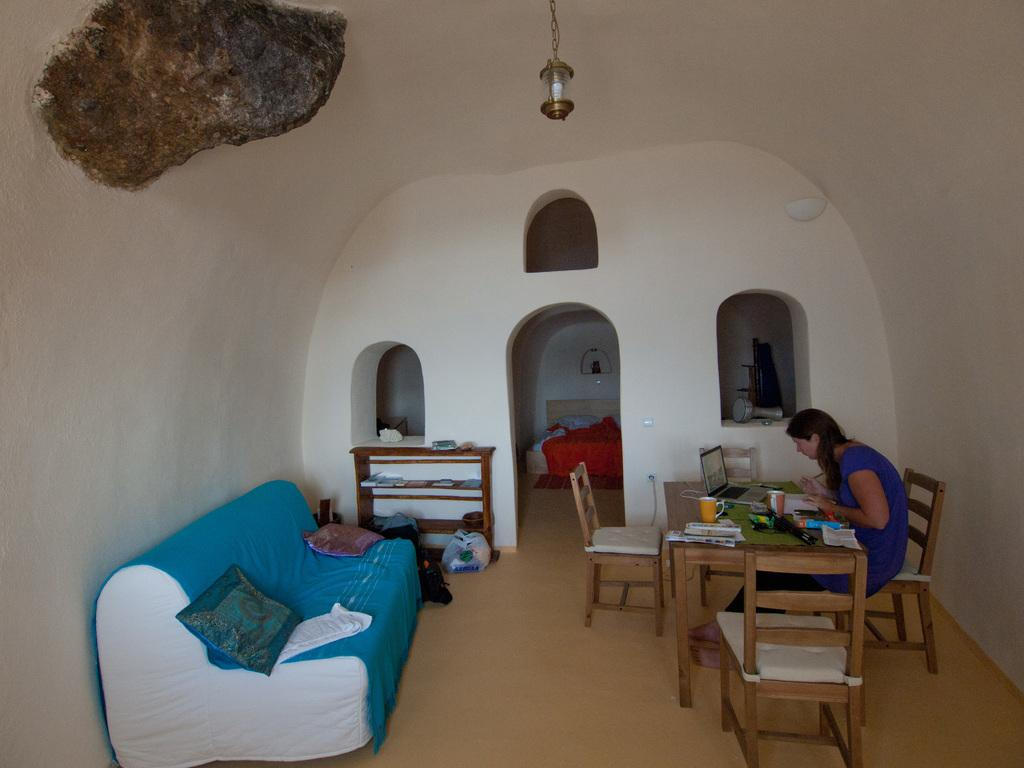What is the woman in the image doing? The woman is sitting on a chair in the image. How many chairs are visible in the image? There are additional chairs in the image. What other furniture is present in the image? There is a table and a sofa with cushions in the image. What color is the crayon on the sofa in the image? There is no crayon present on the sofa in the image. 